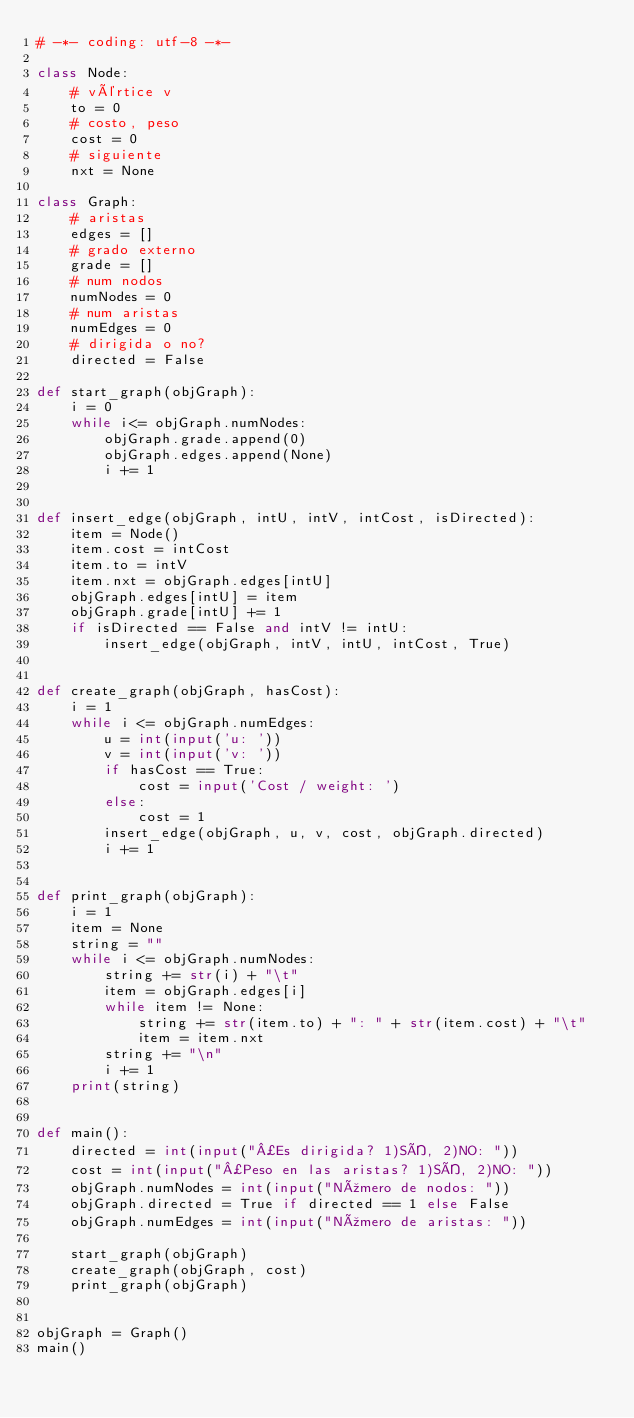Convert code to text. <code><loc_0><loc_0><loc_500><loc_500><_Python_># -*- coding: utf-8 -*-

class Node:
    # vértice v
    to = 0
    # costo, peso
    cost = 0
    # siguiente
    nxt = None

class Graph:
    # aristas
    edges = []
    # grado externo
    grade = []
    # num nodos
    numNodes = 0
    # num aristas
    numEdges = 0
    # dirigida o no?
    directed = False

def start_graph(objGraph):
    i = 0
    while i<= objGraph.numNodes:
        objGraph.grade.append(0)
        objGraph.edges.append(None)
        i += 1


def insert_edge(objGraph, intU, intV, intCost, isDirected):
    item = Node()
    item.cost = intCost
    item.to = intV
    item.nxt = objGraph.edges[intU]
    objGraph.edges[intU] = item
    objGraph.grade[intU] += 1
    if isDirected == False and intV != intU:
        insert_edge(objGraph, intV, intU, intCost, True)


def create_graph(objGraph, hasCost):
    i = 1
    while i <= objGraph.numEdges:
        u = int(input('u: '))
        v = int(input('v: '))
        if hasCost == True:
            cost = input('Cost / weight: ')
        else:
            cost = 1
        insert_edge(objGraph, u, v, cost, objGraph.directed)
        i += 1


def print_graph(objGraph):
    i = 1
    item = None
    string = ""
    while i <= objGraph.numNodes:
        string += str(i) + "\t"
        item = objGraph.edges[i]
        while item != None:
            string += str(item.to) + ": " + str(item.cost) + "\t"
            item = item.nxt
        string += "\n"
        i += 1
    print(string)


def main():
    directed = int(input("¿Es dirigida? 1)SÍ, 2)NO: "))
    cost = int(input("¿Peso en las aristas? 1)SÍ, 2)NO: "))
    objGraph.numNodes = int(input("Número de nodos: "))
    objGraph.directed = True if directed == 1 else False
    objGraph.numEdges = int(input("Número de aristas: "))
    
    start_graph(objGraph)
    create_graph(objGraph, cost)
    print_graph(objGraph)


objGraph = Graph()
main()
</code> 